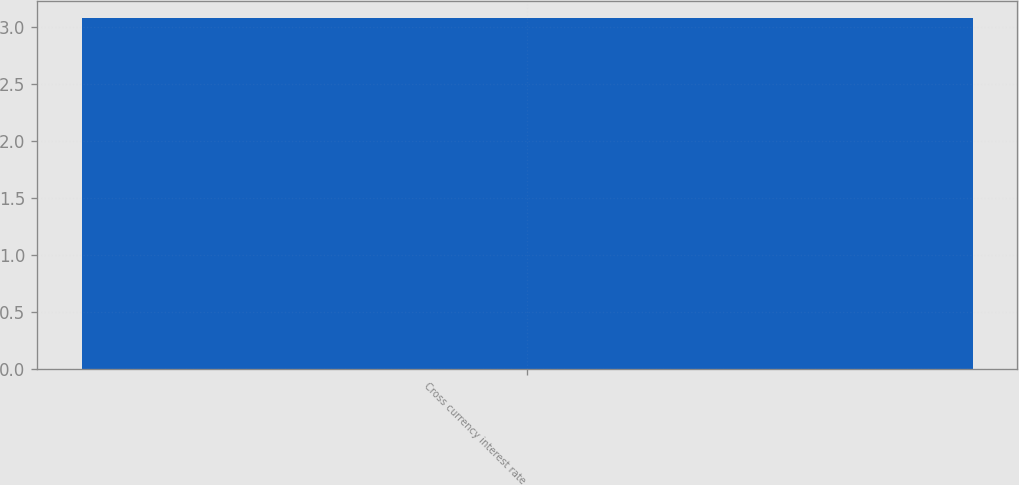Convert chart. <chart><loc_0><loc_0><loc_500><loc_500><bar_chart><fcel>Cross currency interest rate<nl><fcel>3.08<nl></chart> 